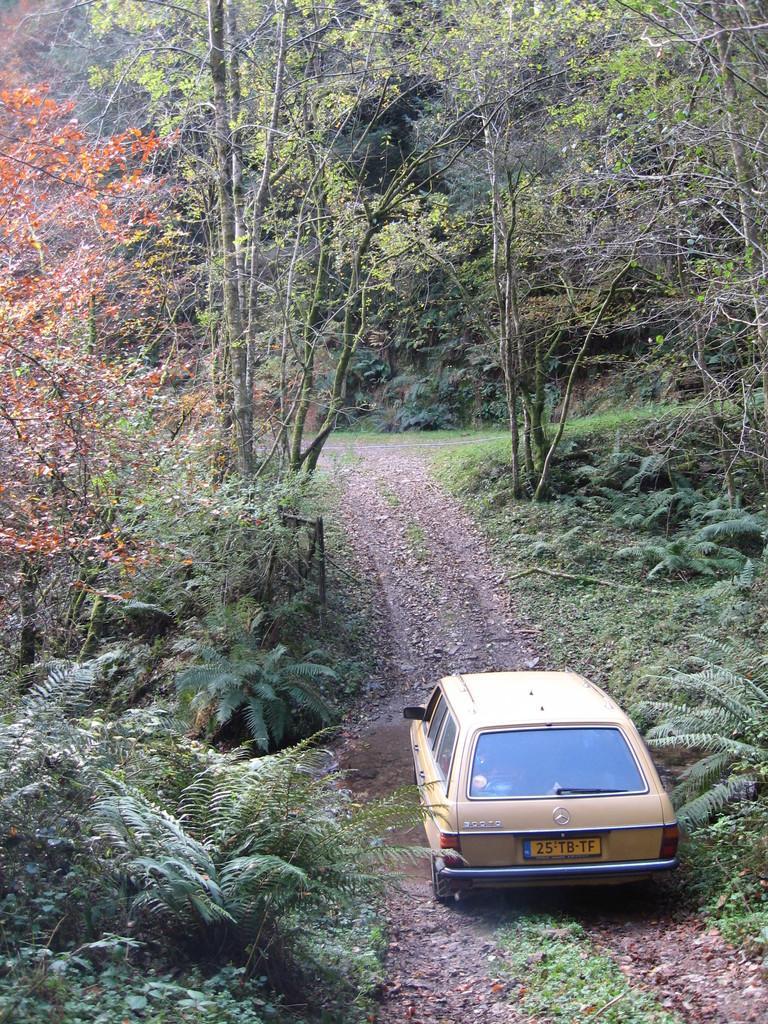Can you describe this image briefly? In this image I can see a car which is cream in color on the ground. I can see few trees on both sides of the car and I can see orange colored leaves to a tree. In the background I can see number of trees. 